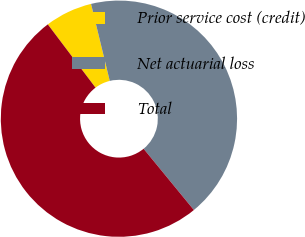<chart> <loc_0><loc_0><loc_500><loc_500><pie_chart><fcel>Prior service cost (credit)<fcel>Net actuarial loss<fcel>Total<nl><fcel>6.49%<fcel>42.86%<fcel>50.65%<nl></chart> 